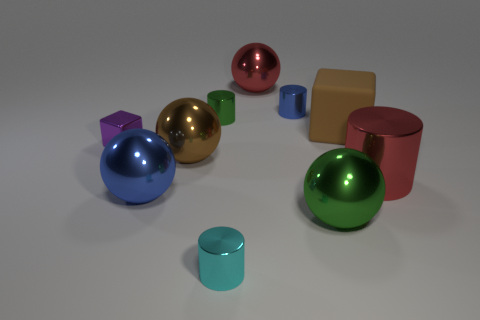Do the block that is left of the big blue metallic thing and the big rubber object have the same color?
Your answer should be compact. No. How many objects are tiny purple rubber objects or tiny metallic cylinders that are in front of the blue ball?
Provide a short and direct response. 1. There is a small object that is both in front of the green metallic cylinder and on the left side of the tiny cyan cylinder; what is its material?
Your answer should be very brief. Metal. What is the sphere that is behind the small purple metallic object made of?
Provide a succinct answer. Metal. What is the color of the big cylinder that is the same material as the small purple object?
Ensure brevity in your answer.  Red. There is a small cyan metallic object; is it the same shape as the big red object to the right of the tiny blue metal cylinder?
Offer a terse response. Yes. Are there any brown rubber things to the left of the large green metal thing?
Give a very brief answer. No. What is the material of the large sphere that is the same color as the big rubber thing?
Your answer should be very brief. Metal. Does the green cylinder have the same size as the blue shiny object that is behind the big cylinder?
Provide a succinct answer. Yes. Is there a large thing that has the same color as the large metal cylinder?
Offer a very short reply. Yes. 